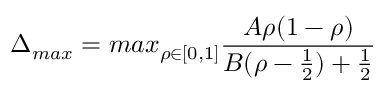<formula> <loc_0><loc_0><loc_500><loc_500>\Delta _ { \max } = \max _ { \rho \in [ 0 , 1 ] } \frac { A \rho ( 1 - \rho ) } { B ( \rho - \frac { 1 } { 2 } ) + \frac { 1 } { 2 } }</formula> 